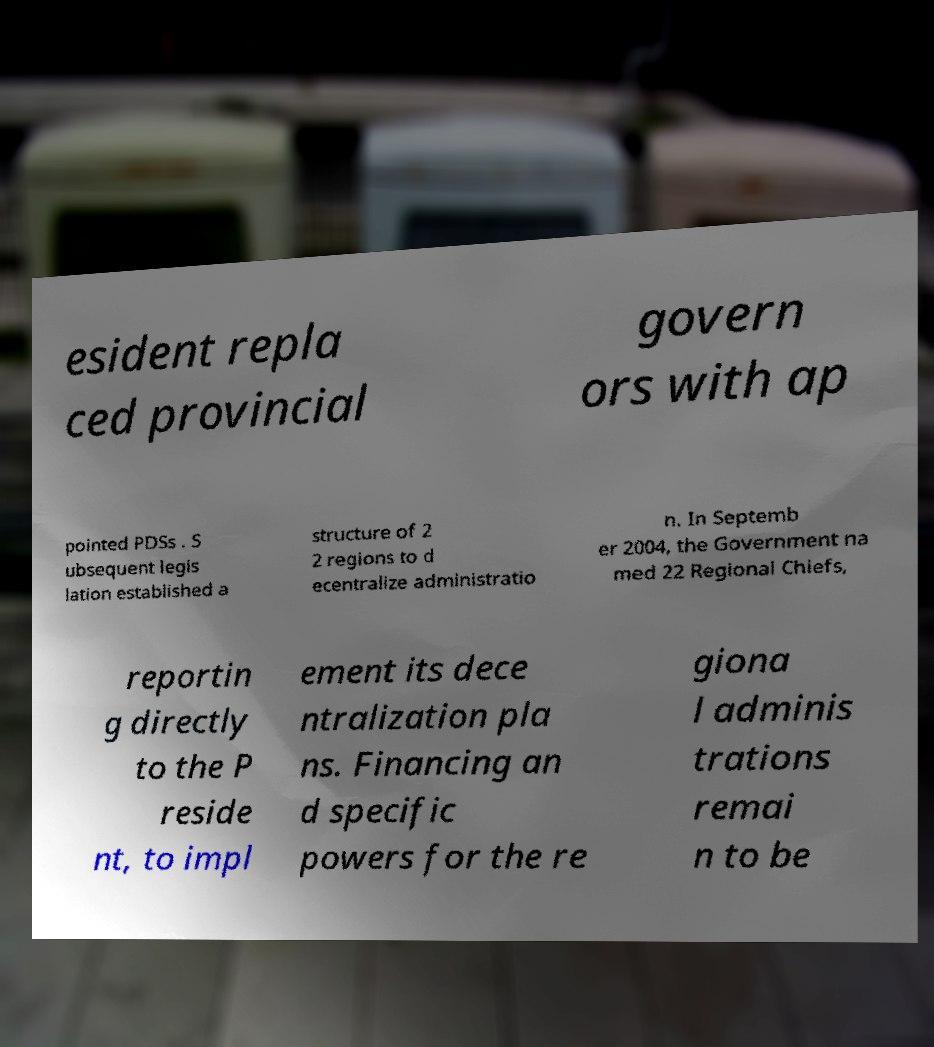For documentation purposes, I need the text within this image transcribed. Could you provide that? esident repla ced provincial govern ors with ap pointed PDSs . S ubsequent legis lation established a structure of 2 2 regions to d ecentralize administratio n. In Septemb er 2004, the Government na med 22 Regional Chiefs, reportin g directly to the P reside nt, to impl ement its dece ntralization pla ns. Financing an d specific powers for the re giona l adminis trations remai n to be 